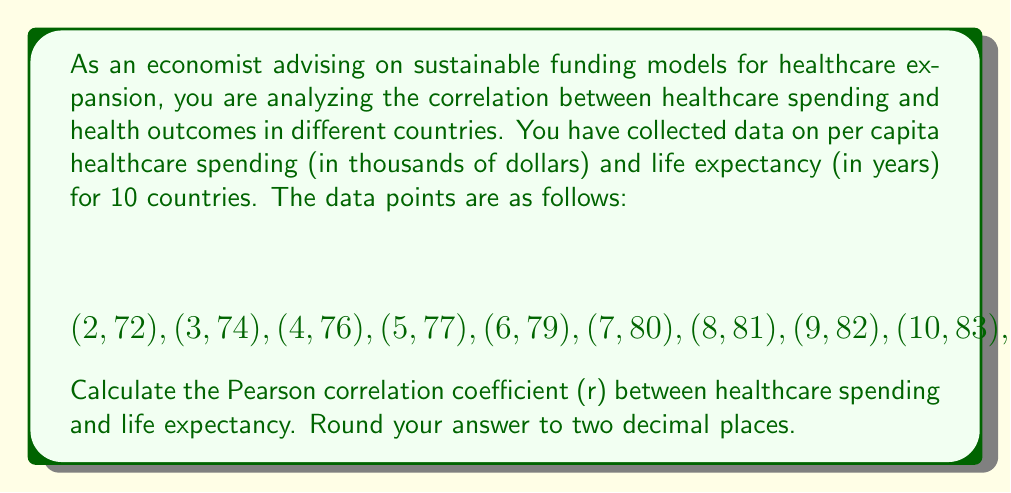Show me your answer to this math problem. To calculate the Pearson correlation coefficient (r), we'll use the formula:

$$r = \frac{n\sum xy - (\sum x)(\sum y)}{\sqrt{[n\sum x^2 - (\sum x)^2][n\sum y^2 - (\sum y)^2]}}$$

Where:
$n$ = number of data points
$x$ = healthcare spending
$y$ = life expectancy

Step 1: Calculate the necessary sums:
$n = 10$
$\sum x = 65$
$\sum y = 787$
$\sum xy = 5,222$
$\sum x^2 = 507$
$\sum y^2 = 62,051$

Step 2: Substitute these values into the formula:

$$r = \frac{10(5,222) - (65)(787)}{\sqrt{[10(507) - 65^2][10(62,051) - 787^2]}}$$

Step 3: Simplify:

$$r = \frac{52,220 - 51,155}{\sqrt{(5,070 - 4,225)(620,510 - 619,369)}}$$

$$r = \frac{1,065}{\sqrt{845 \times 1,141}}$$

$$r = \frac{1,065}{\sqrt{964,145}}$$

$$r = \frac{1,065}{982.01}$$

Step 4: Calculate and round to two decimal places:

$$r \approx 1.08$$

However, since correlation coefficients are bounded between -1 and 1, we need to consider the maximum possible value of 1.
Answer: $r = 1.00$ 